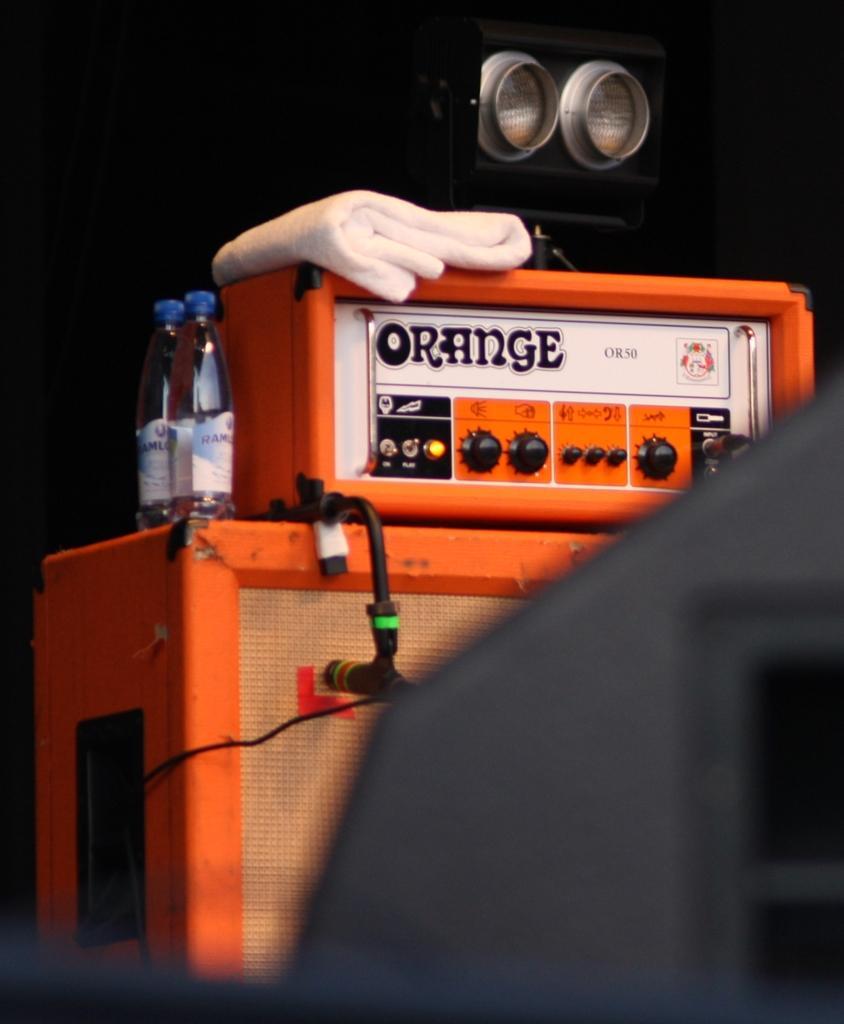In one or two sentences, can you explain what this image depicts? In this picture there is an electric box which is placed at the center of the image and there are two water bottles at the left side of the image. 